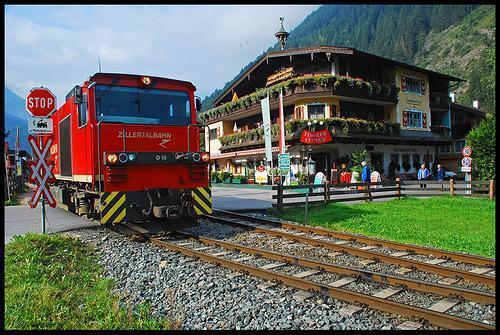How many people are visible in the photo?
Give a very brief answer. 3. How many train cars are there?
Give a very brief answer. 1. 